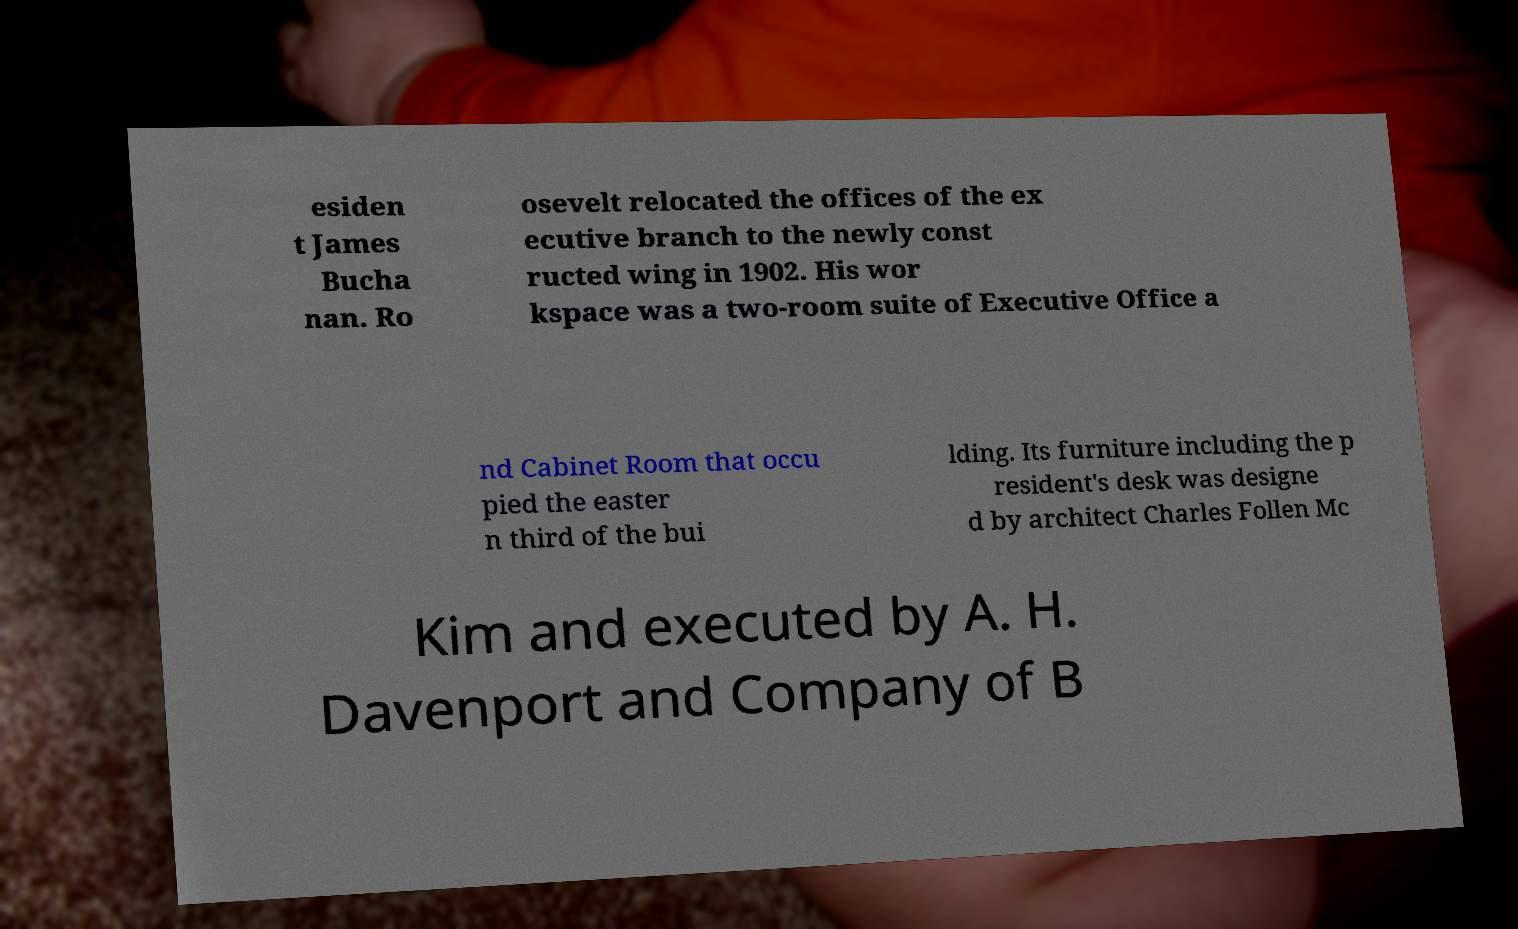Please read and relay the text visible in this image. What does it say? esiden t James Bucha nan. Ro osevelt relocated the offices of the ex ecutive branch to the newly const ructed wing in 1902. His wor kspace was a two-room suite of Executive Office a nd Cabinet Room that occu pied the easter n third of the bui lding. Its furniture including the p resident's desk was designe d by architect Charles Follen Mc Kim and executed by A. H. Davenport and Company of B 